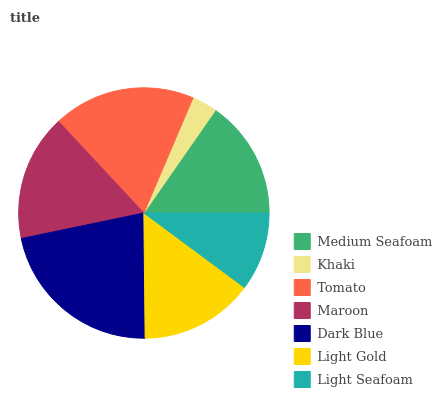Is Khaki the minimum?
Answer yes or no. Yes. Is Dark Blue the maximum?
Answer yes or no. Yes. Is Tomato the minimum?
Answer yes or no. No. Is Tomato the maximum?
Answer yes or no. No. Is Tomato greater than Khaki?
Answer yes or no. Yes. Is Khaki less than Tomato?
Answer yes or no. Yes. Is Khaki greater than Tomato?
Answer yes or no. No. Is Tomato less than Khaki?
Answer yes or no. No. Is Medium Seafoam the high median?
Answer yes or no. Yes. Is Medium Seafoam the low median?
Answer yes or no. Yes. Is Maroon the high median?
Answer yes or no. No. Is Dark Blue the low median?
Answer yes or no. No. 